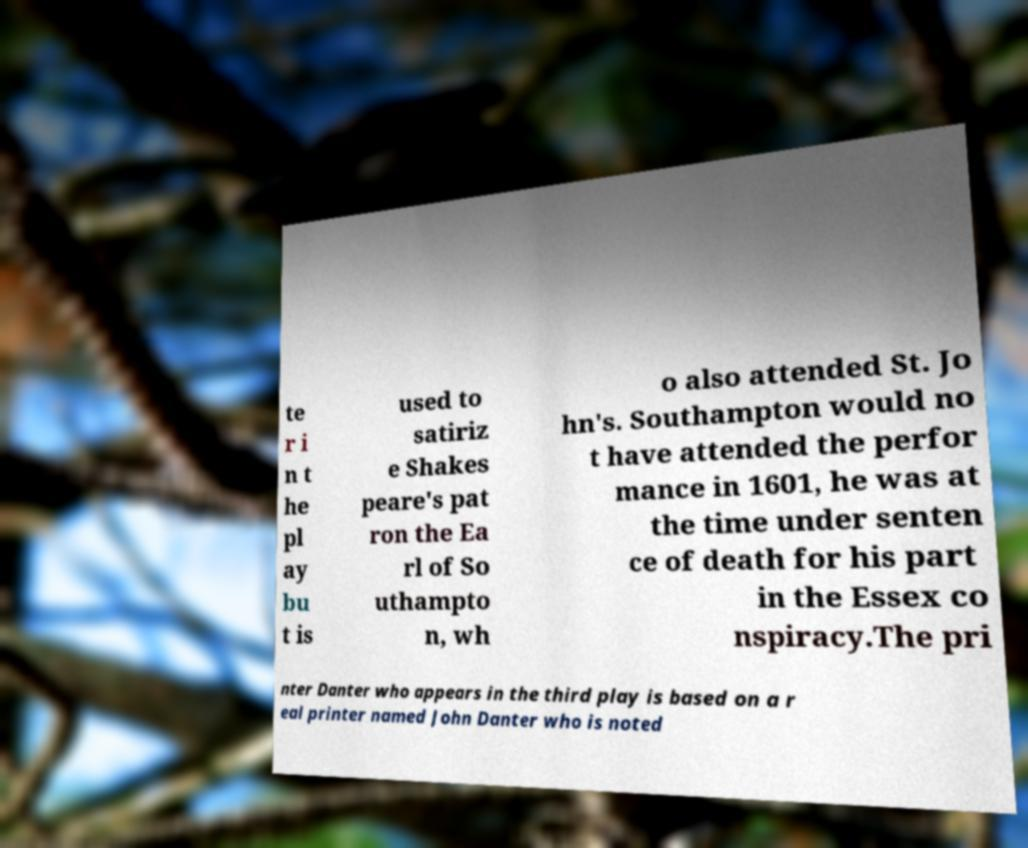Can you read and provide the text displayed in the image?This photo seems to have some interesting text. Can you extract and type it out for me? te r i n t he pl ay bu t is used to satiriz e Shakes peare's pat ron the Ea rl of So uthampto n, wh o also attended St. Jo hn's. Southampton would no t have attended the perfor mance in 1601, he was at the time under senten ce of death for his part in the Essex co nspiracy.The pri nter Danter who appears in the third play is based on a r eal printer named John Danter who is noted 